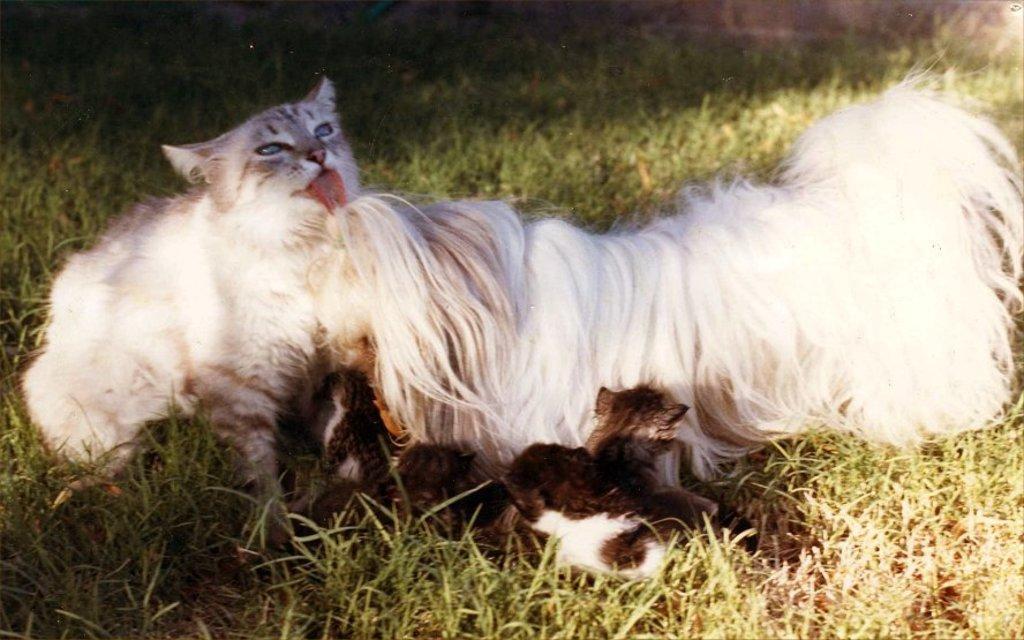How would you summarize this image in a sentence or two? In this image we can see cat, dog and kittens on the ground. 